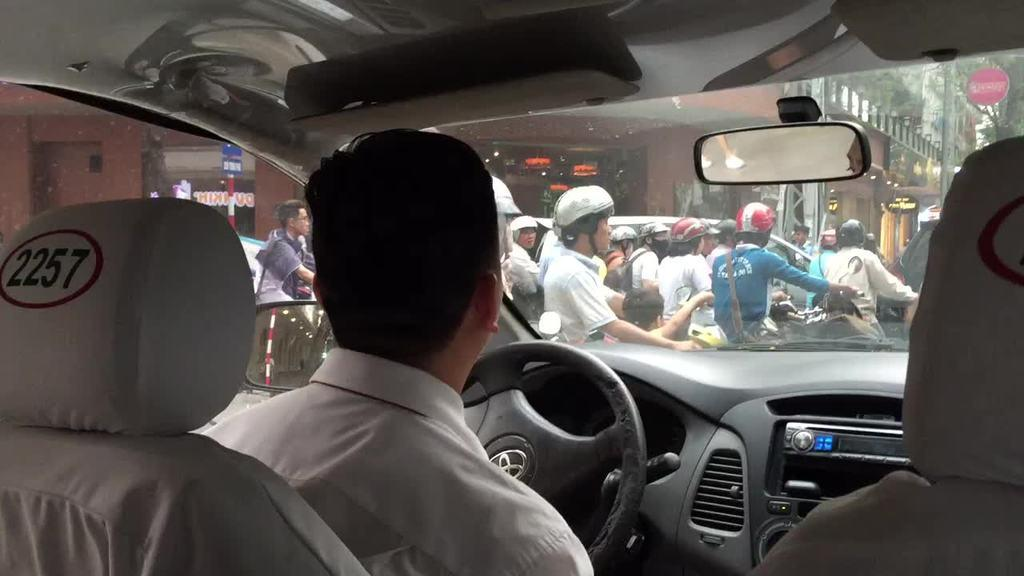Where was the image taken? The image was taken inside a car. Who is in the driver seat of the car? There is a man sitting in the driver seat. What can be seen outside the car in the image? There are many people in front of the car. Are the people outside the car wearing any protective gear? None of the people in front of the car are wearing helmets. What is visible in the background of the image? There is a building in the background of the image. Can you see the hand of the person holding the receipt in the image? There is no hand or receipt present in the image. 